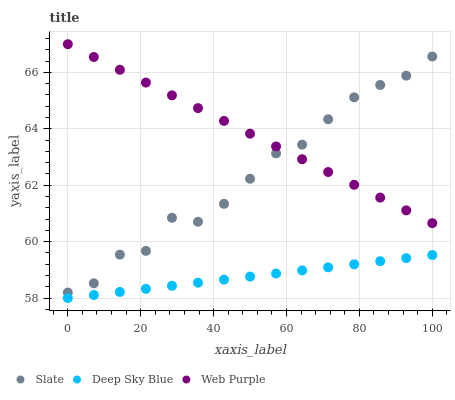Does Deep Sky Blue have the minimum area under the curve?
Answer yes or no. Yes. Does Web Purple have the maximum area under the curve?
Answer yes or no. Yes. Does Web Purple have the minimum area under the curve?
Answer yes or no. No. Does Deep Sky Blue have the maximum area under the curve?
Answer yes or no. No. Is Deep Sky Blue the smoothest?
Answer yes or no. Yes. Is Slate the roughest?
Answer yes or no. Yes. Is Web Purple the smoothest?
Answer yes or no. No. Is Web Purple the roughest?
Answer yes or no. No. Does Deep Sky Blue have the lowest value?
Answer yes or no. Yes. Does Web Purple have the lowest value?
Answer yes or no. No. Does Web Purple have the highest value?
Answer yes or no. Yes. Does Deep Sky Blue have the highest value?
Answer yes or no. No. Is Deep Sky Blue less than Slate?
Answer yes or no. Yes. Is Web Purple greater than Deep Sky Blue?
Answer yes or no. Yes. Does Web Purple intersect Slate?
Answer yes or no. Yes. Is Web Purple less than Slate?
Answer yes or no. No. Is Web Purple greater than Slate?
Answer yes or no. No. Does Deep Sky Blue intersect Slate?
Answer yes or no. No. 